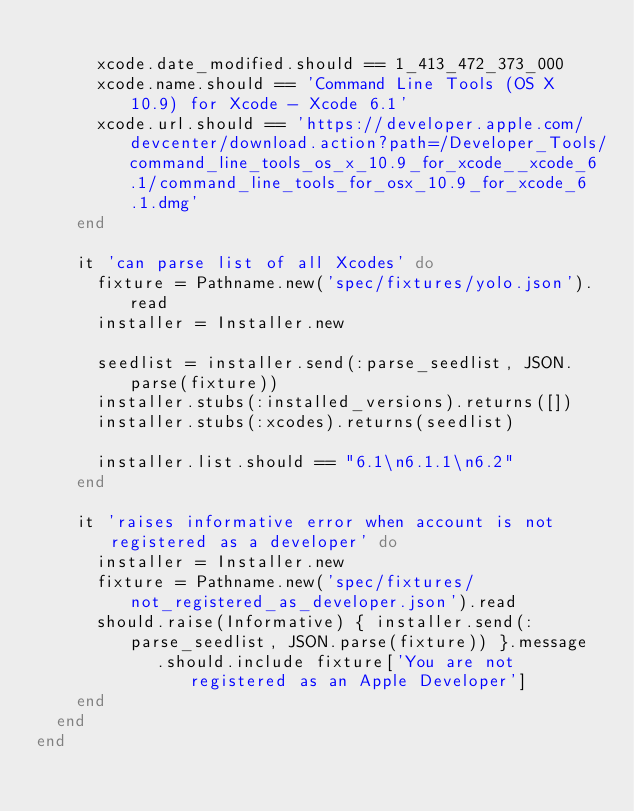<code> <loc_0><loc_0><loc_500><loc_500><_Ruby_>
      xcode.date_modified.should == 1_413_472_373_000
      xcode.name.should == 'Command Line Tools (OS X 10.9) for Xcode - Xcode 6.1'
      xcode.url.should == 'https://developer.apple.com/devcenter/download.action?path=/Developer_Tools/command_line_tools_os_x_10.9_for_xcode__xcode_6.1/command_line_tools_for_osx_10.9_for_xcode_6.1.dmg'
    end

    it 'can parse list of all Xcodes' do
      fixture = Pathname.new('spec/fixtures/yolo.json').read
      installer = Installer.new

      seedlist = installer.send(:parse_seedlist, JSON.parse(fixture))
      installer.stubs(:installed_versions).returns([])
      installer.stubs(:xcodes).returns(seedlist)

      installer.list.should == "6.1\n6.1.1\n6.2"
    end

    it 'raises informative error when account is not registered as a developer' do
      installer = Installer.new
      fixture = Pathname.new('spec/fixtures/not_registered_as_developer.json').read
      should.raise(Informative) { installer.send(:parse_seedlist, JSON.parse(fixture)) }.message
            .should.include fixture['You are not registered as an Apple Developer']
    end
  end
end
</code> 